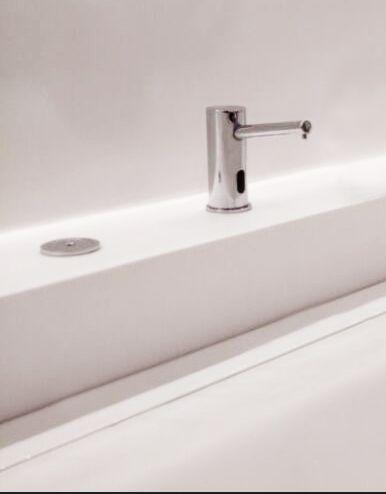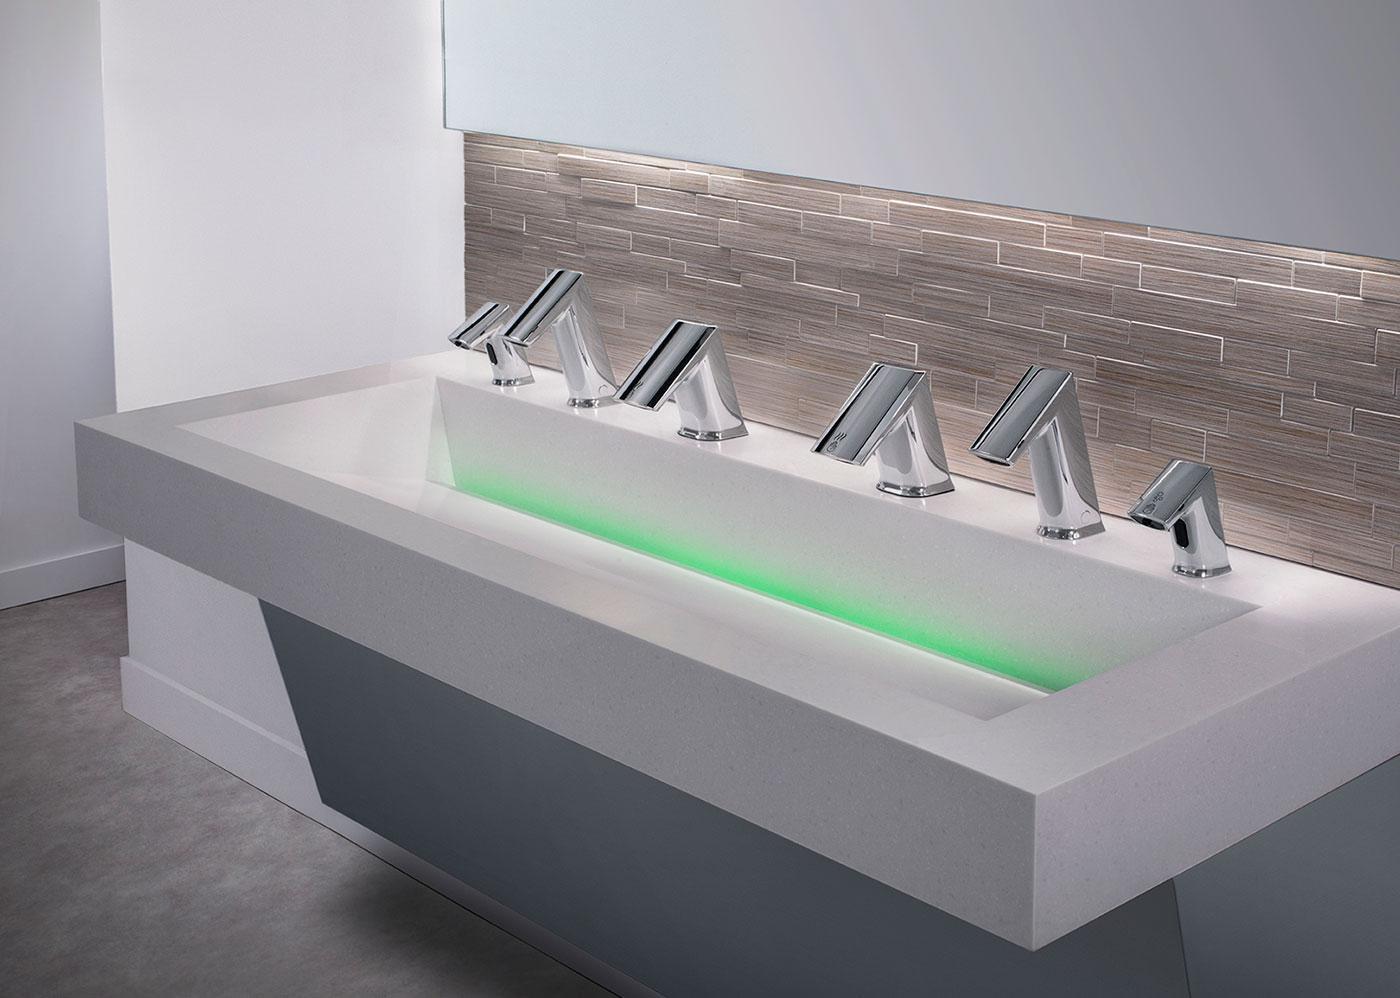The first image is the image on the left, the second image is the image on the right. Evaluate the accuracy of this statement regarding the images: "more than 3 sinks are on the same vanity". Is it true? Answer yes or no. No. The first image is the image on the left, the second image is the image on the right. Considering the images on both sides, is "More than one cord is visible underneath the faucets and counter-top." valid? Answer yes or no. No. 